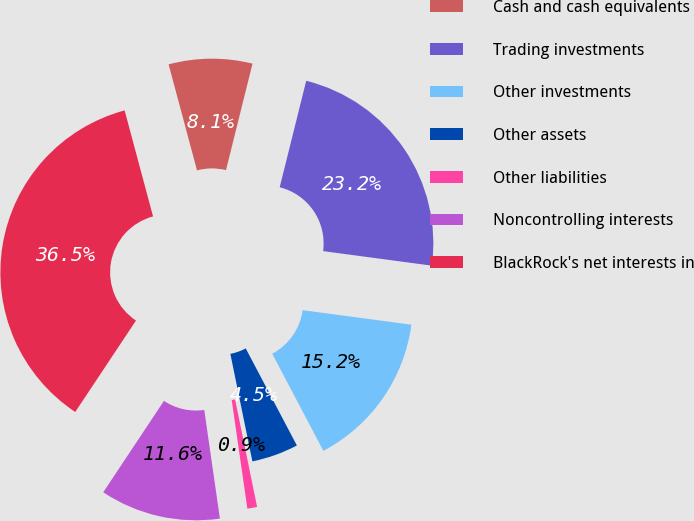Convert chart. <chart><loc_0><loc_0><loc_500><loc_500><pie_chart><fcel>Cash and cash equivalents<fcel>Trading investments<fcel>Other investments<fcel>Other assets<fcel>Other liabilities<fcel>Noncontrolling interests<fcel>BlackRock's net interests in<nl><fcel>8.05%<fcel>23.23%<fcel>15.17%<fcel>4.5%<fcel>0.94%<fcel>11.61%<fcel>36.5%<nl></chart> 